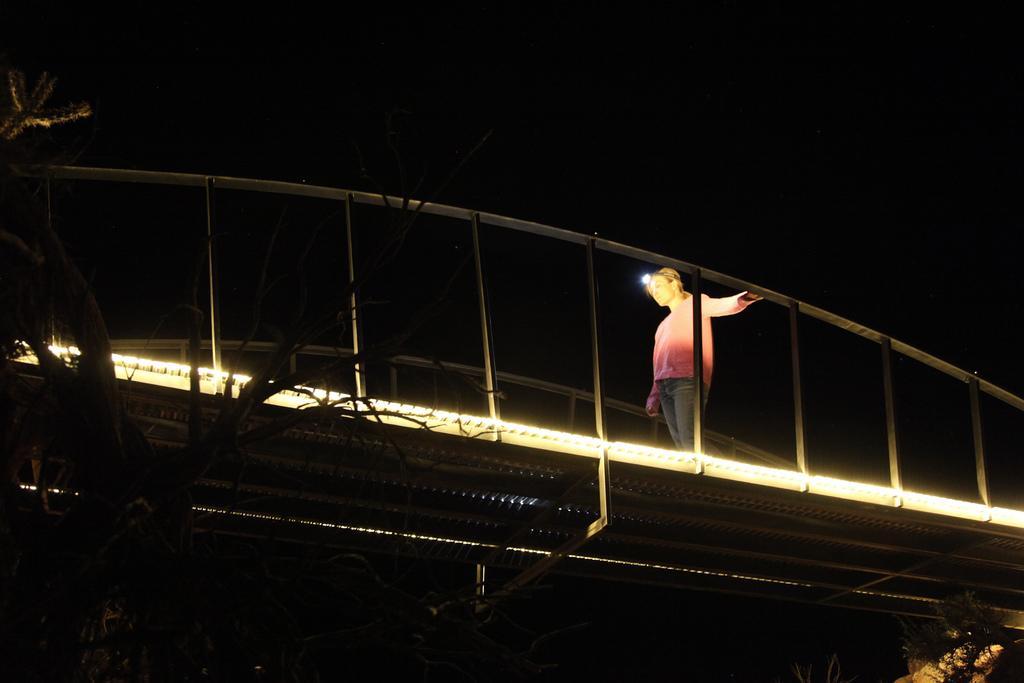How would you summarize this image in a sentence or two? In this image we can see a person walking on the bridge. There is a bridge in the image. There is a tree in the image. There is a dark background in the image. 